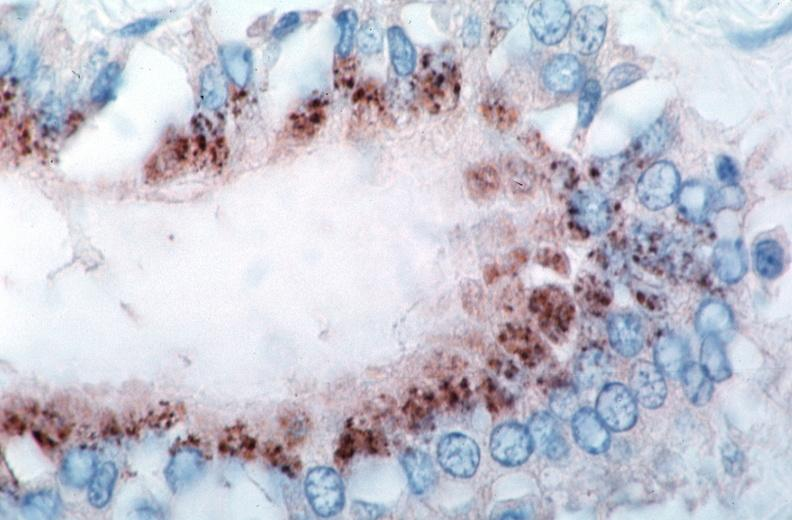does polycystic disease show vasculitis?
Answer the question using a single word or phrase. No 